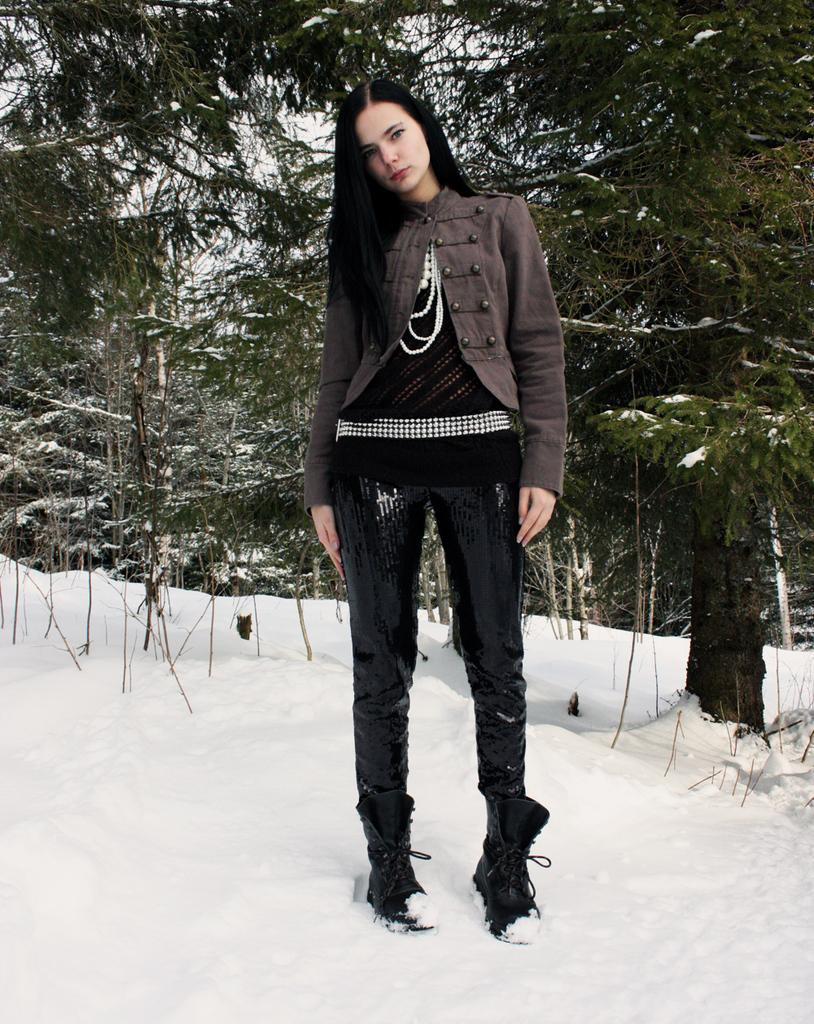Who is the main subject in the image? There is a girl in the image. What is the girl standing on? The girl is standing on the snow. What can be seen in the background of the image? There are trees visible in the background of the image. What type of clothing is the girl wearing? The girl is wearing a jacket. What is the condition of the ground in the image? The ground is covered in snow. Can you see any worms crawling on the snow in the image? There are no worms visible in the image; the focus is on the girl standing on the snow. 